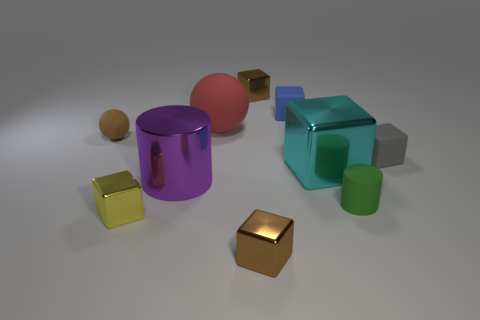Can you tell me the colors of all the objects in the image? Certainly! In the image, we have objects in several distinct colors: a pink sphere, a brown and a golden cube, a green cylinder, a yellow cube, a blue cube, and a purple cylinder with a cut-through hole. 